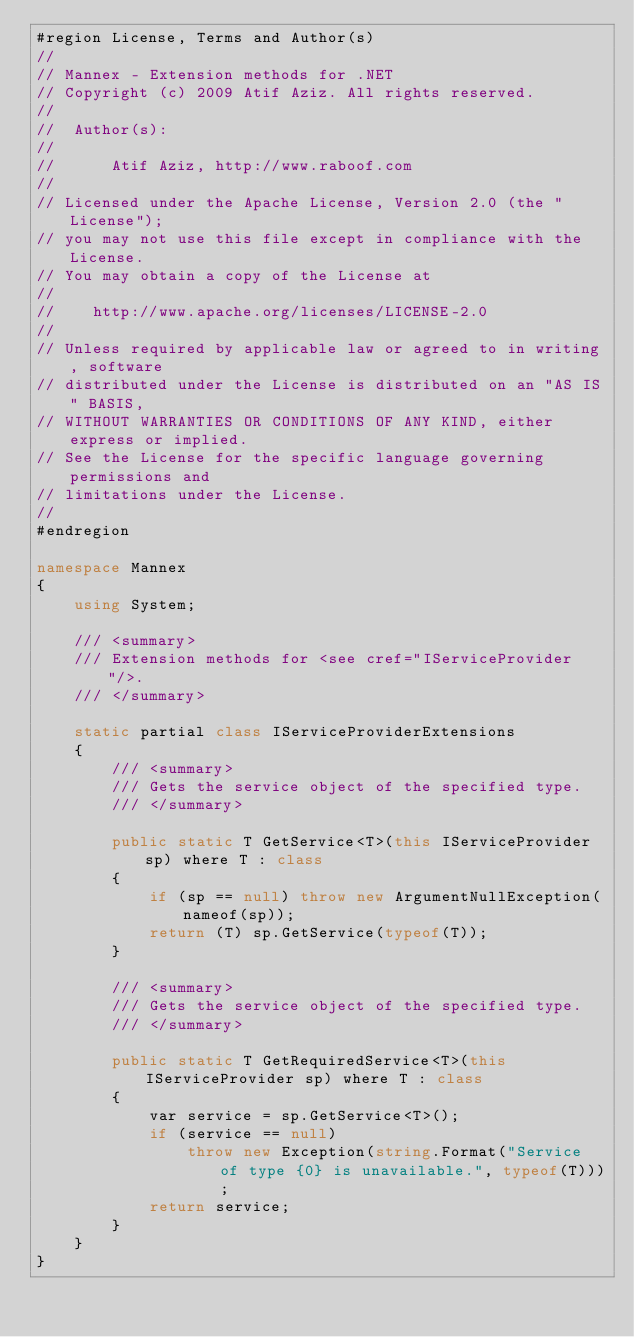Convert code to text. <code><loc_0><loc_0><loc_500><loc_500><_C#_>#region License, Terms and Author(s)
//
// Mannex - Extension methods for .NET
// Copyright (c) 2009 Atif Aziz. All rights reserved.
//
//  Author(s):
//
//      Atif Aziz, http://www.raboof.com
//
// Licensed under the Apache License, Version 2.0 (the "License");
// you may not use this file except in compliance with the License.
// You may obtain a copy of the License at
//
//    http://www.apache.org/licenses/LICENSE-2.0
//
// Unless required by applicable law or agreed to in writing, software
// distributed under the License is distributed on an "AS IS" BASIS,
// WITHOUT WARRANTIES OR CONDITIONS OF ANY KIND, either express or implied.
// See the License for the specific language governing permissions and
// limitations under the License.
//
#endregion

namespace Mannex
{
    using System;

    /// <summary>
    /// Extension methods for <see cref="IServiceProvider"/>.
    /// </summary>

    static partial class IServiceProviderExtensions
    {
        /// <summary>
        /// Gets the service object of the specified type.
        /// </summary>

        public static T GetService<T>(this IServiceProvider sp) where T : class
        {
            if (sp == null) throw new ArgumentNullException(nameof(sp));
            return (T) sp.GetService(typeof(T));
        }

        /// <summary>
        /// Gets the service object of the specified type.
        /// </summary>

        public static T GetRequiredService<T>(this IServiceProvider sp) where T : class
        {
            var service = sp.GetService<T>();
            if (service == null)
                throw new Exception(string.Format("Service of type {0} is unavailable.", typeof(T)));
            return service;
        }
    }
}
</code> 